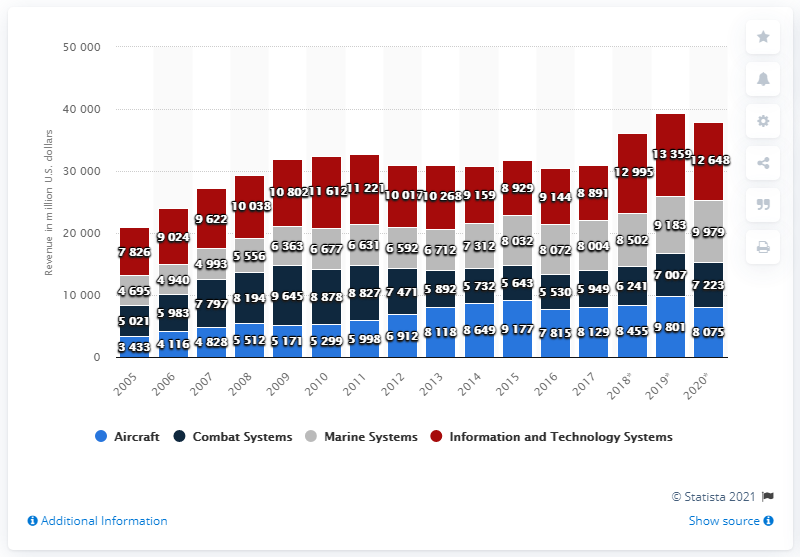Identify some key points in this picture. In the United States in 2020, the revenue of the combat systems product group was 7,223. In 2020, General Dynamics reported a significant increase in revenue from information and technology systems, totaling $126,480. 